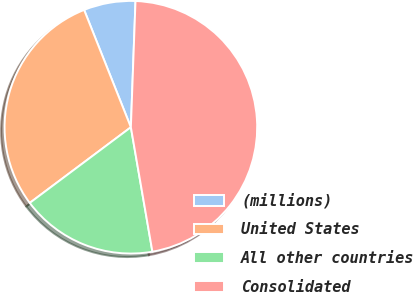Convert chart. <chart><loc_0><loc_0><loc_500><loc_500><pie_chart><fcel>(millions)<fcel>United States<fcel>All other countries<fcel>Consolidated<nl><fcel>6.62%<fcel>29.19%<fcel>17.5%<fcel>46.69%<nl></chart> 